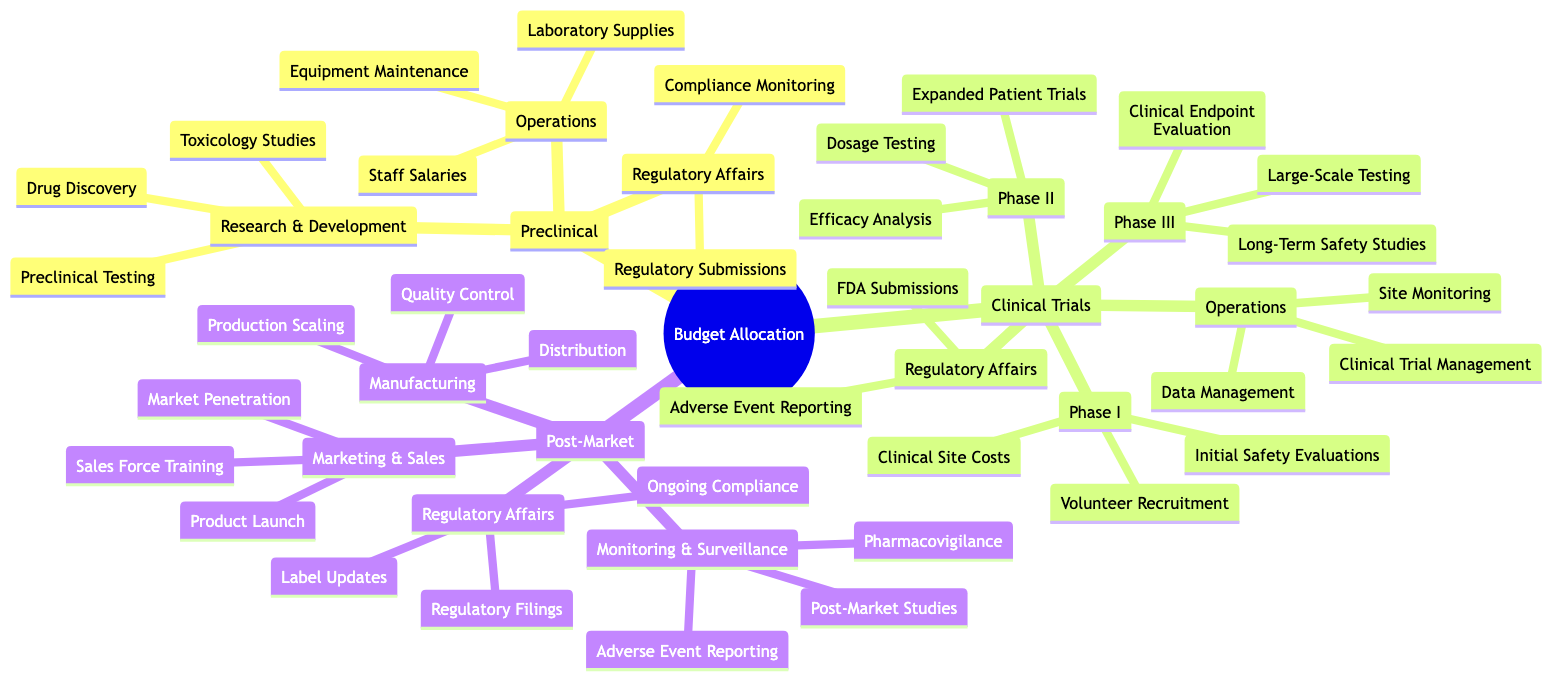What are the subcategories under Preclinical? The Preclinical phase has three main subcategories: Research & Development, Operations, and Regulatory Affairs. Each of these contains specific activities related to drug development, such as Drug Discovery under Research & Development.
Answer: Research & Development, Operations, Regulatory Affairs How many phases are included in Clinical Trials? The Clinical Trials section is divided into three specific phases: Phase I, Phase II, and Phase III, each focusing on different aspects of clinical evaluation. There are also subcategories for Operations and Regulatory Affairs.
Answer: Three What is one of the activities listed under Phase II of Clinical Trials? Phase II includes Expanded Patient Trials, which is an essential activity to test the drug's efficacy and dosage on a larger group of patients after initial safety evaluations.
Answer: Expanded Patient Trials Which category includes the activity "Quality Control"? Quality Control is included under the Manufacturing subcategory within the Post-Market phase, which focuses on ensuring the drug's production and distribution meet the necessary quality standards.
Answer: Manufacturing What are the three areas listed in Regulatory Affairs across all phases? Regulatory Affairs encompasses activities related to compliance at every phase: Regulatory Submissions in Preclinical, FDA Submissions in Clinical Trials, and Ongoing Compliance in Post-Market.
Answer: Regulatory Submissions, FDA Submissions, Ongoing Compliance How does the number of activities under Post-Market compare to those in Preclinical? Post-Market consists of three main areas, each with multiple activities, which may be more numerous compared to the Preclinical phase that has three defined subcategories with fewer activities.
Answer: More What is the last activity listed under Monitoring & Surveillance? The final activity listed under the Monitoring & Surveillance category in the Post-Market section is Adverse Event Reporting, which tracks any negative side effects experienced by patients after the drug is marketed.
Answer: Adverse Event Reporting What main subcategory of Clinical Trials follows Phase I? The main subcategory that follows Phase I is Phase II, which focuses on expanded testing for dosage and efficacy following initial safety evaluations.
Answer: Phase II Which area oversees the activities of volunteer recruitment during Clinical Trials? Volunteer Recruitment is managed under the Phase I subcategory of Clinical Trials, which is dedicated to gathering participants for initial drug testing.
Answer: Phase I 